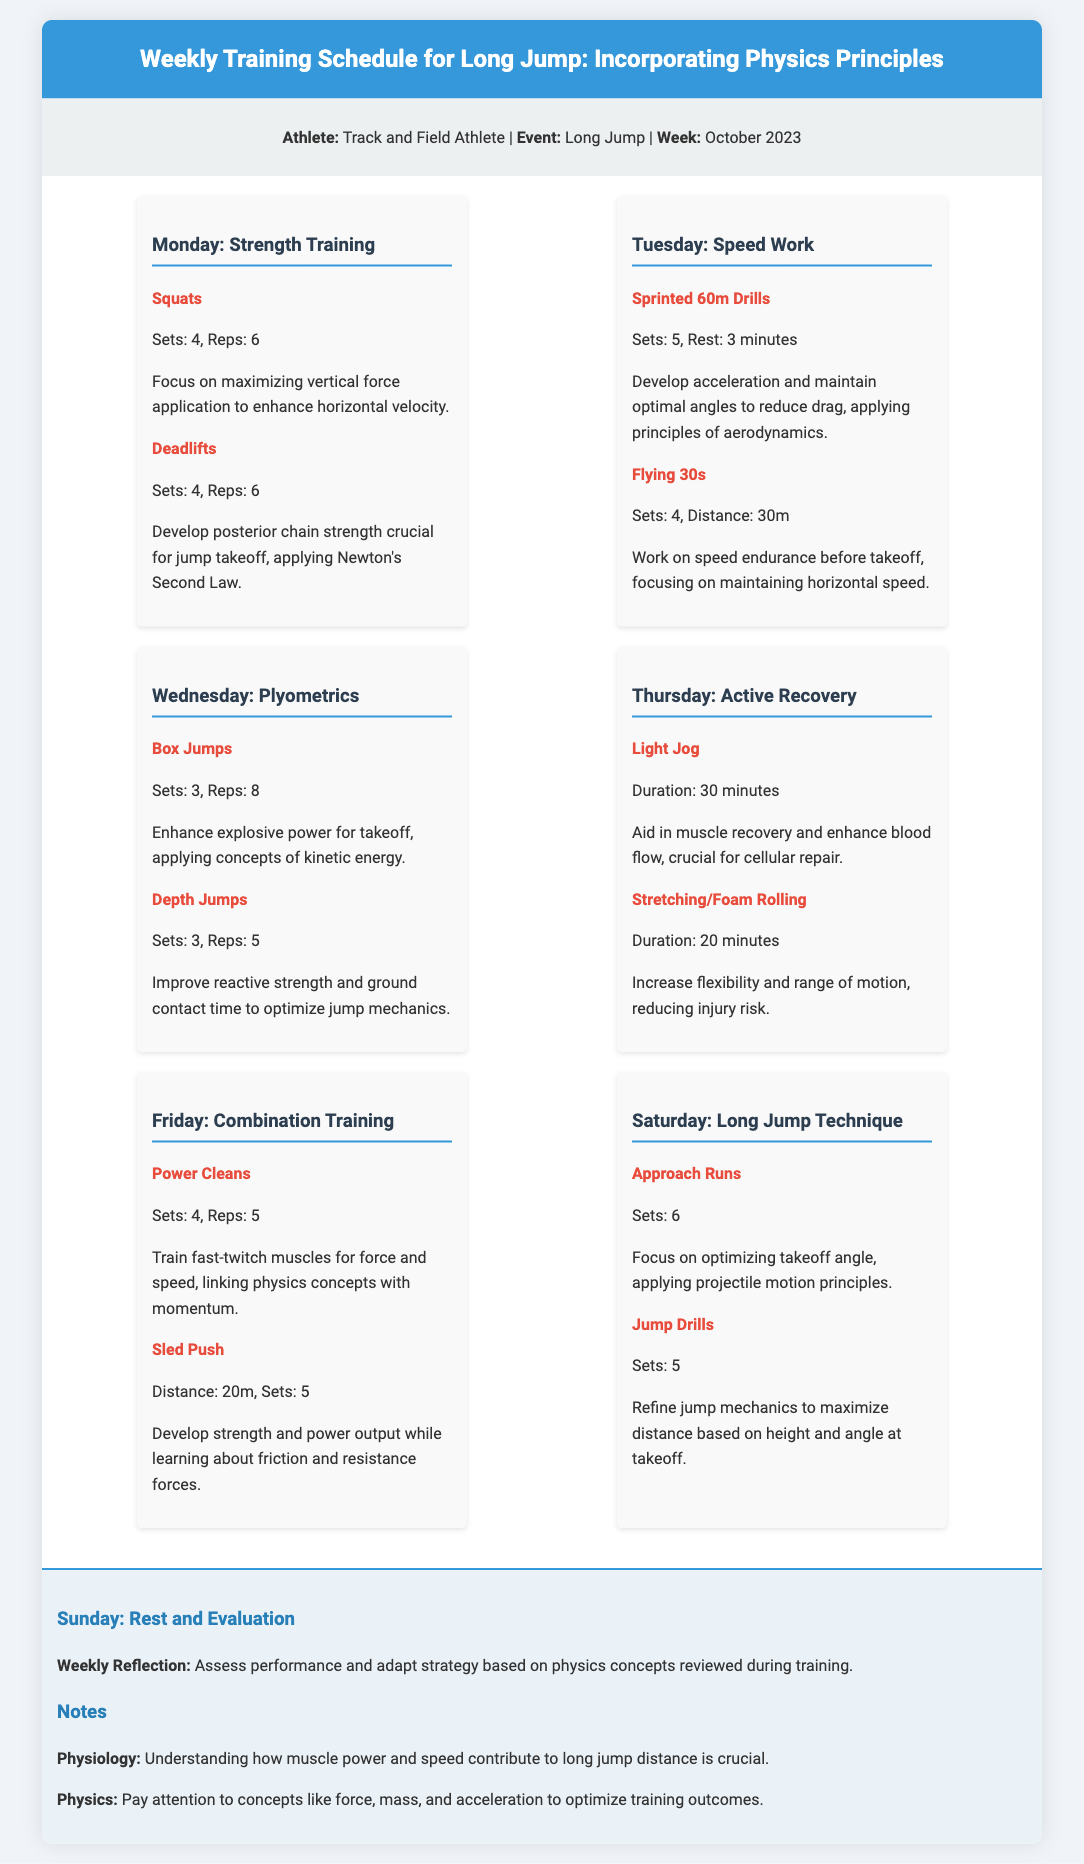what is the primary focus of Monday's training? The primary focus of Monday's training is to maximize vertical force application and develop posterior chain strength.
Answer: strength training how many sets and reps are recommended for Squats? The recommended sets for Squats is 4 and the reps is 6.
Answer: 4 sets, 6 reps what exercise is performed on Friday to develop fast-twitch muscles? The exercise performed on Friday to develop fast-twitch muscles is Power Cleans.
Answer: Power Cleans what principle does the athlete apply while working on Approach Runs on Saturday? The principle applied while working on Approach Runs is projectile motion.
Answer: projectile motion how long should the Light Jog last on Thursday? The Light Jog should last for 30 minutes to aid in muscle recovery.
Answer: 30 minutes 